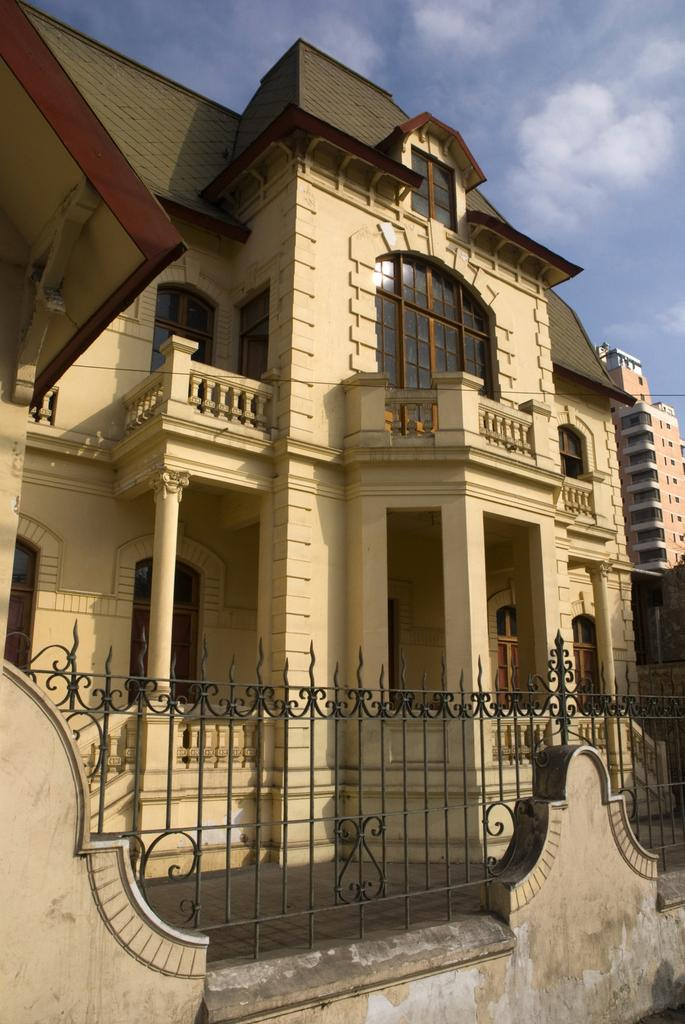What structures are present in the image? There are buildings in the image. What can be seen in the sky in the background of the image? There are clouds visible in the sky in the background of the image. What type of stew is being cooked in the image? There is no stew present in the image; it features buildings and clouds. How many rings can be seen on the stranger's fingers in the image? There is no stranger present in the image, so it is not possible to determine the number of rings on their fingers. 